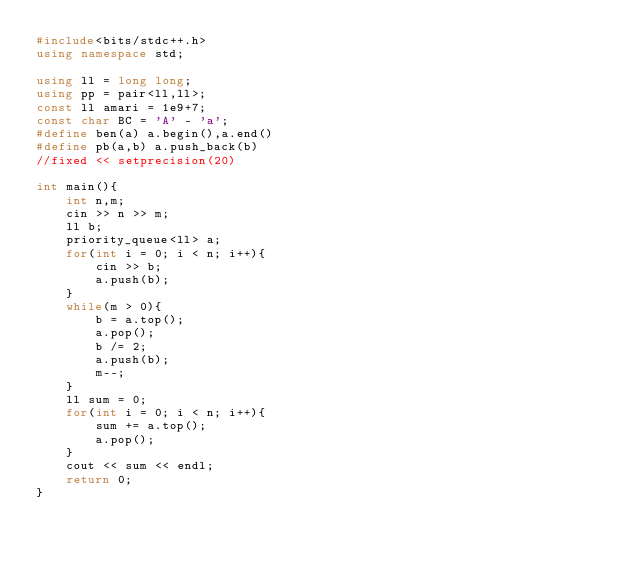<code> <loc_0><loc_0><loc_500><loc_500><_C++_>#include<bits/stdc++.h>
using namespace std;

using ll = long long;
using pp = pair<ll,ll>;
const ll amari = 1e9+7;
const char BC = 'A' - 'a';
#define ben(a) a.begin(),a.end()
#define pb(a,b) a.push_back(b)
//fixed << setprecision(20)

int main(){
	int n,m;
	cin >> n >> m;
	ll b;
	priority_queue<ll> a;
	for(int i = 0; i < n; i++){
		cin >> b;
		a.push(b);
	}
	while(m > 0){
		b = a.top();
		a.pop();
		b /= 2;
		a.push(b);
		m--;
	}
	ll sum = 0;
	for(int i = 0; i < n; i++){
		sum += a.top();
		a.pop();
	}
	cout << sum << endl;
	return 0;
}
 </code> 